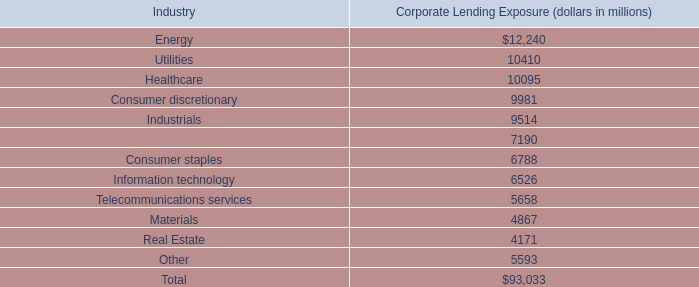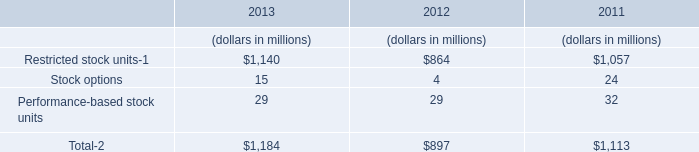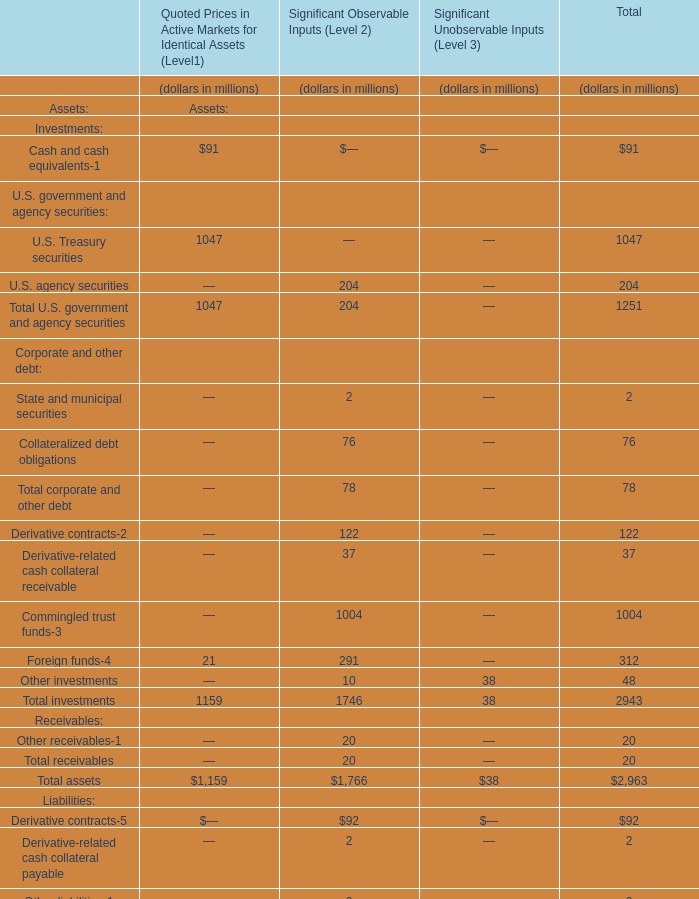how much of the december 31 , 2013 201cevent- driven 201d loans and commitments will mature in 2014 , in billions? 
Computations: (9.5 * 33%)
Answer: 3.135. 